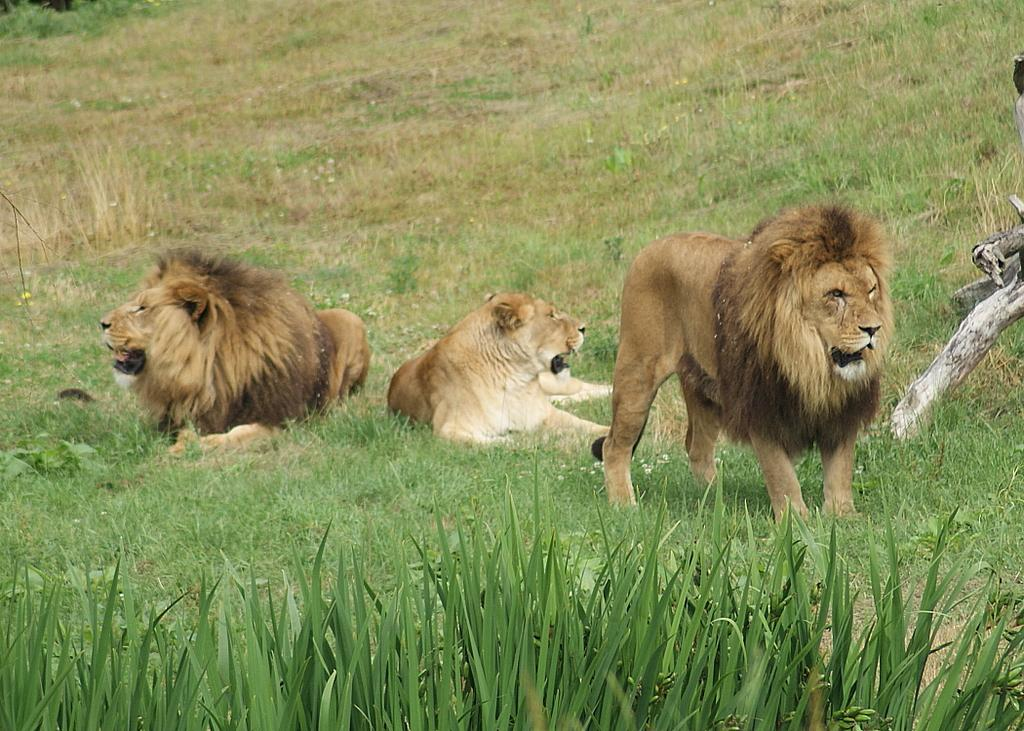How many lions are sitting in the image? There are two lions sitting in the image. What is the position of the third lion in the image? There is one lion standing in the image. What type of vegetation is visible in the image? There is grass, a branch of a tree, and other plants visible in the image. What type of account does the lion have in the image? There is no mention of an account in the image, as it features lions and vegetation. 